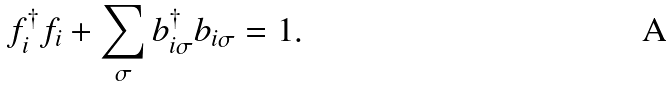Convert formula to latex. <formula><loc_0><loc_0><loc_500><loc_500>f ^ { \dagger } _ { i } f _ { i } + \sum _ { \sigma } b ^ { \dagger } _ { i \sigma } b _ { i \sigma } = 1 .</formula> 